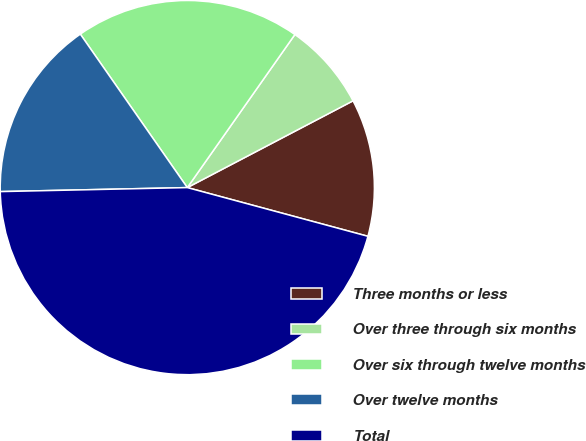Convert chart to OTSL. <chart><loc_0><loc_0><loc_500><loc_500><pie_chart><fcel>Three months or less<fcel>Over three through six months<fcel>Over six through twelve months<fcel>Over twelve months<fcel>Total<nl><fcel>11.87%<fcel>7.57%<fcel>19.44%<fcel>15.65%<fcel>45.46%<nl></chart> 